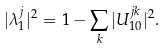<formula> <loc_0><loc_0><loc_500><loc_500>| \lambda ^ { j } _ { 1 } | ^ { 2 } = 1 - \sum _ { k } | U _ { 1 0 } ^ { j k } | ^ { 2 } .</formula> 